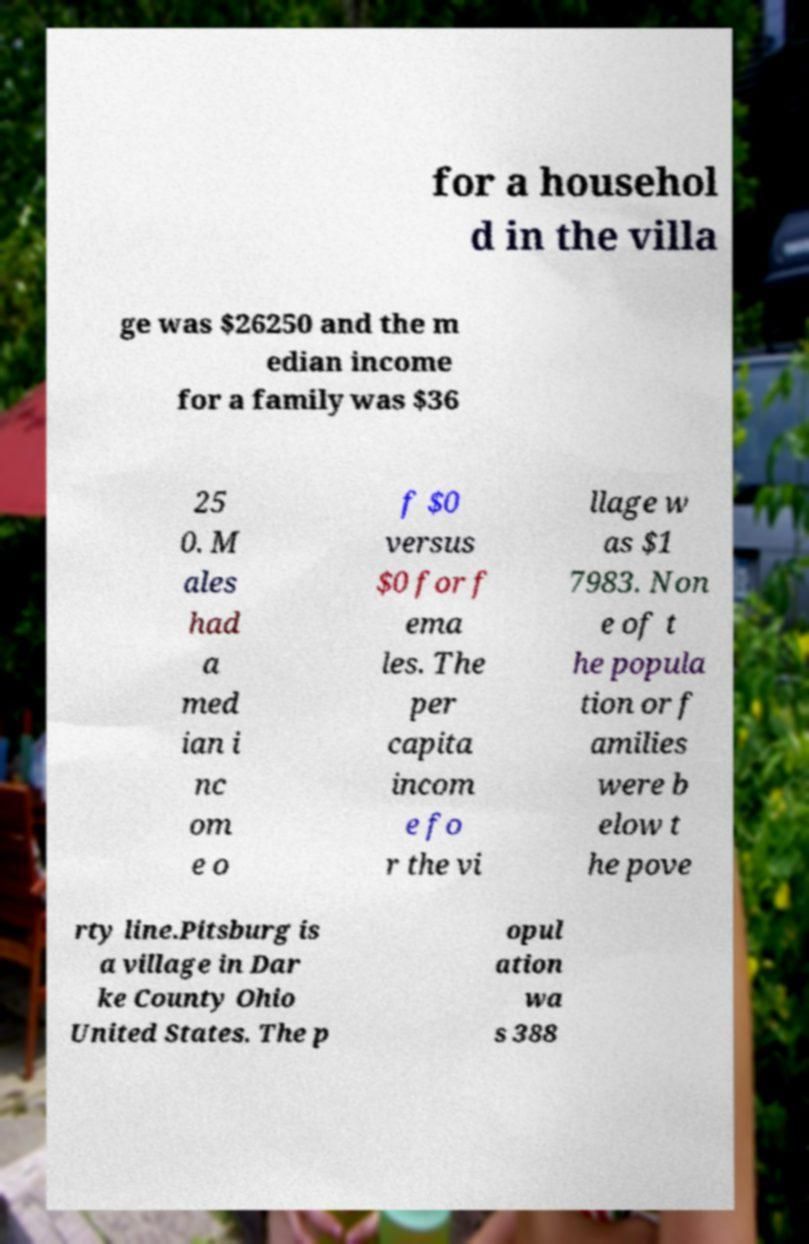Please read and relay the text visible in this image. What does it say? for a househol d in the villa ge was $26250 and the m edian income for a family was $36 25 0. M ales had a med ian i nc om e o f $0 versus $0 for f ema les. The per capita incom e fo r the vi llage w as $1 7983. Non e of t he popula tion or f amilies were b elow t he pove rty line.Pitsburg is a village in Dar ke County Ohio United States. The p opul ation wa s 388 